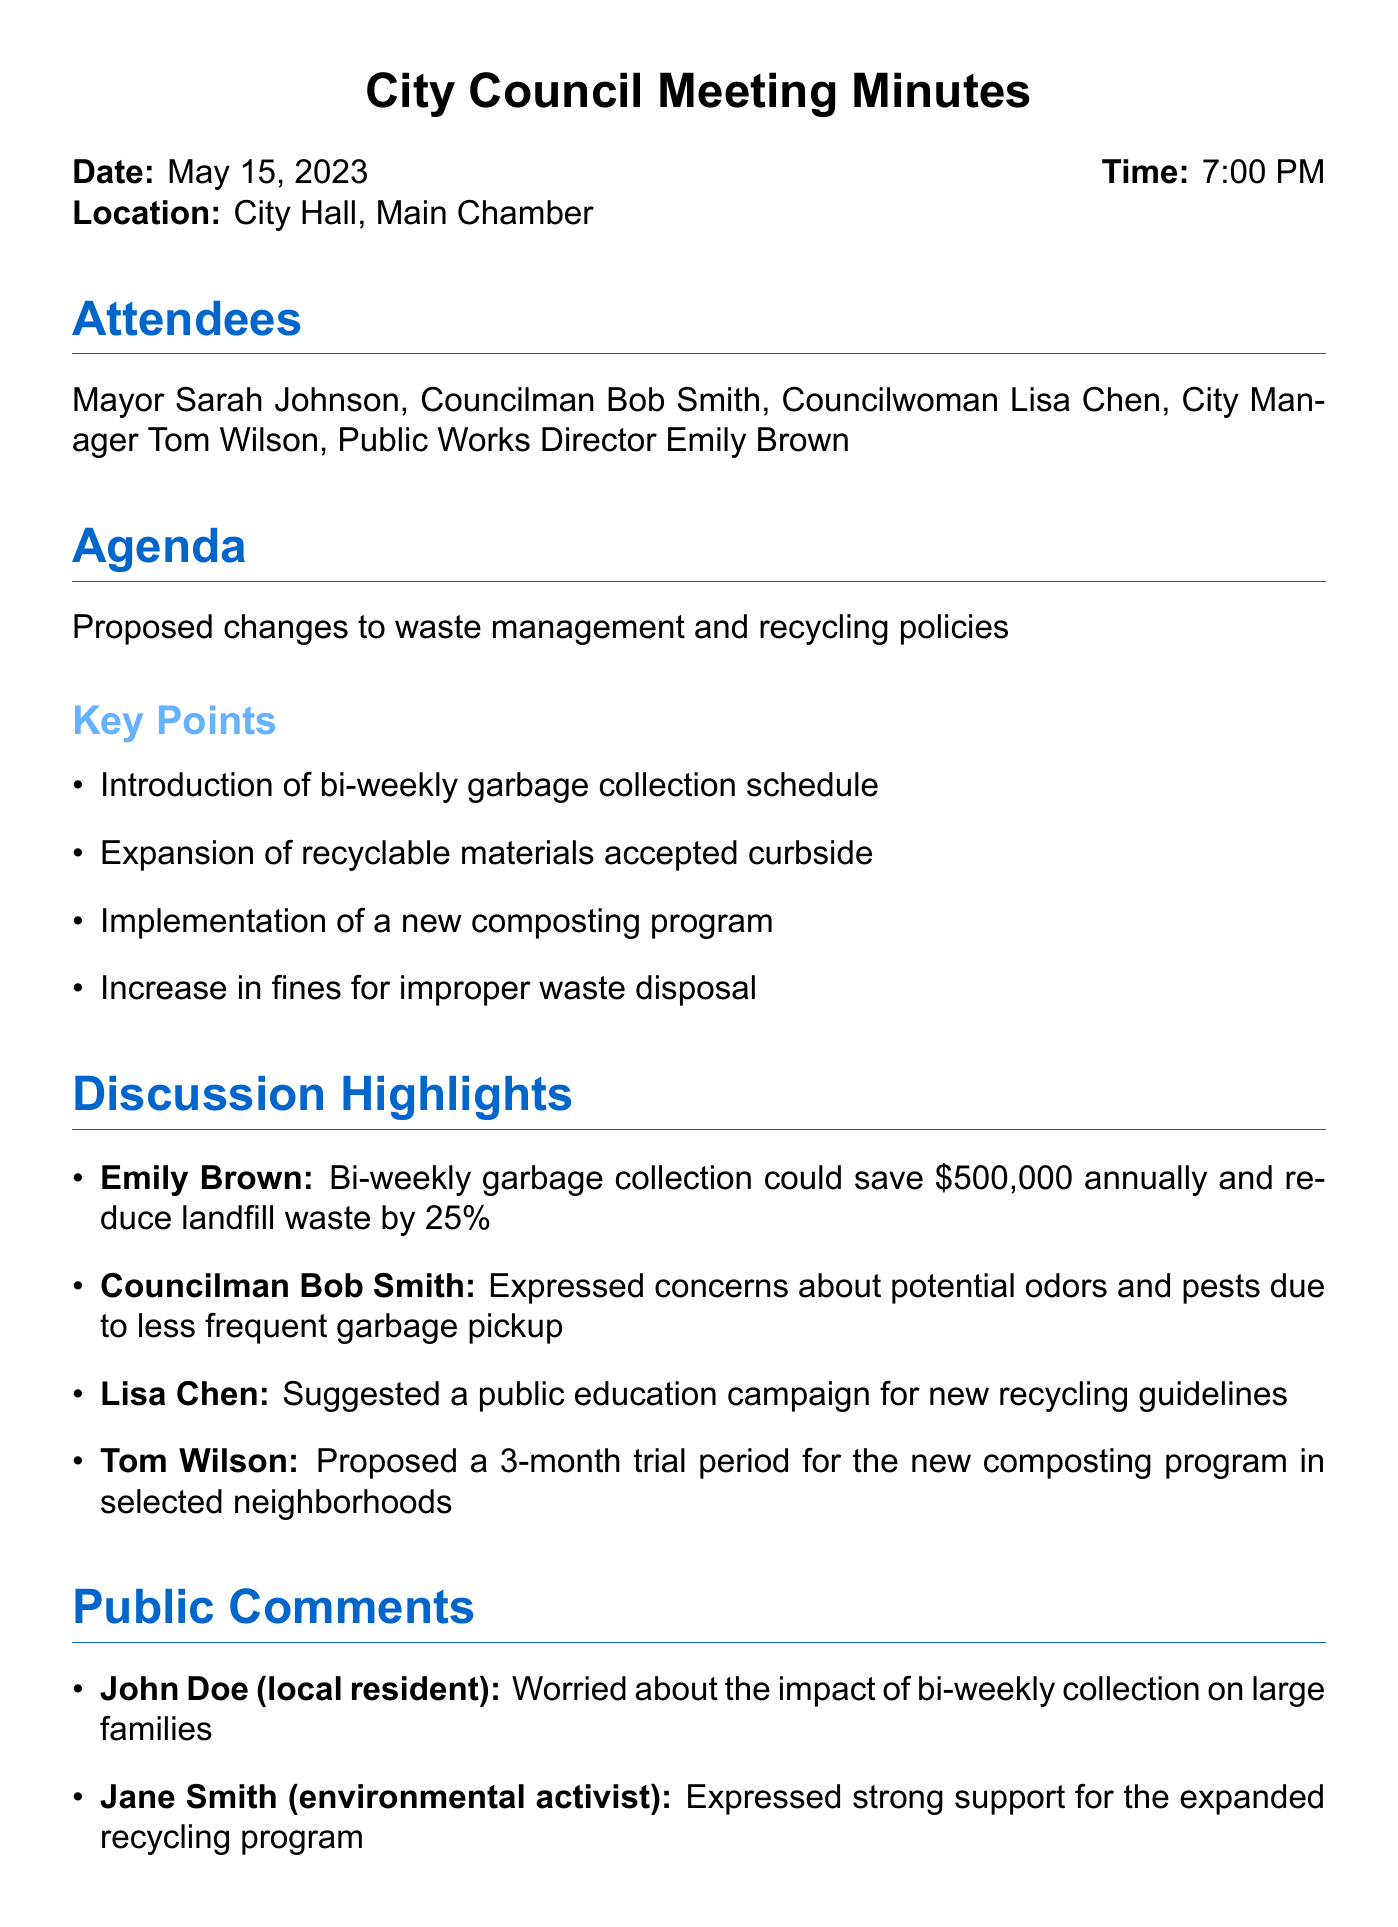What is the date of the meeting? The date of the meeting is stated explicitly at the beginning of the document.
Answer: May 15, 2023 What time did the meeting start? The starting time of the meeting is provided in the meeting details section.
Answer: 7:00 PM Who proposed the new composting program? The speaker who proposed the new composting program is mentioned in the discussion highlights section.
Answer: Tom Wilson How much could bi-weekly garbage collection save annually? The document highlights the financial savings projected by the proposed changes.
Answer: $500,000 What is one concern raised about bi-weekly garbage collection? The concern is provided in the discussion highlights section regarding potential issues.
Answer: Odors and pests What action item involves the Finance Department? The action items indicate specific responsibilities assigned to different departments.
Answer: Analyze potential cost savings When is the public hearing scheduled? The next steps section lists important upcoming dates.
Answer: May 29, 2023 What public change was suggested by Lisa Chen? The suggestion made by Lisa Chen addresses how residents can adapt to new guidelines.
Answer: Public education campaign 